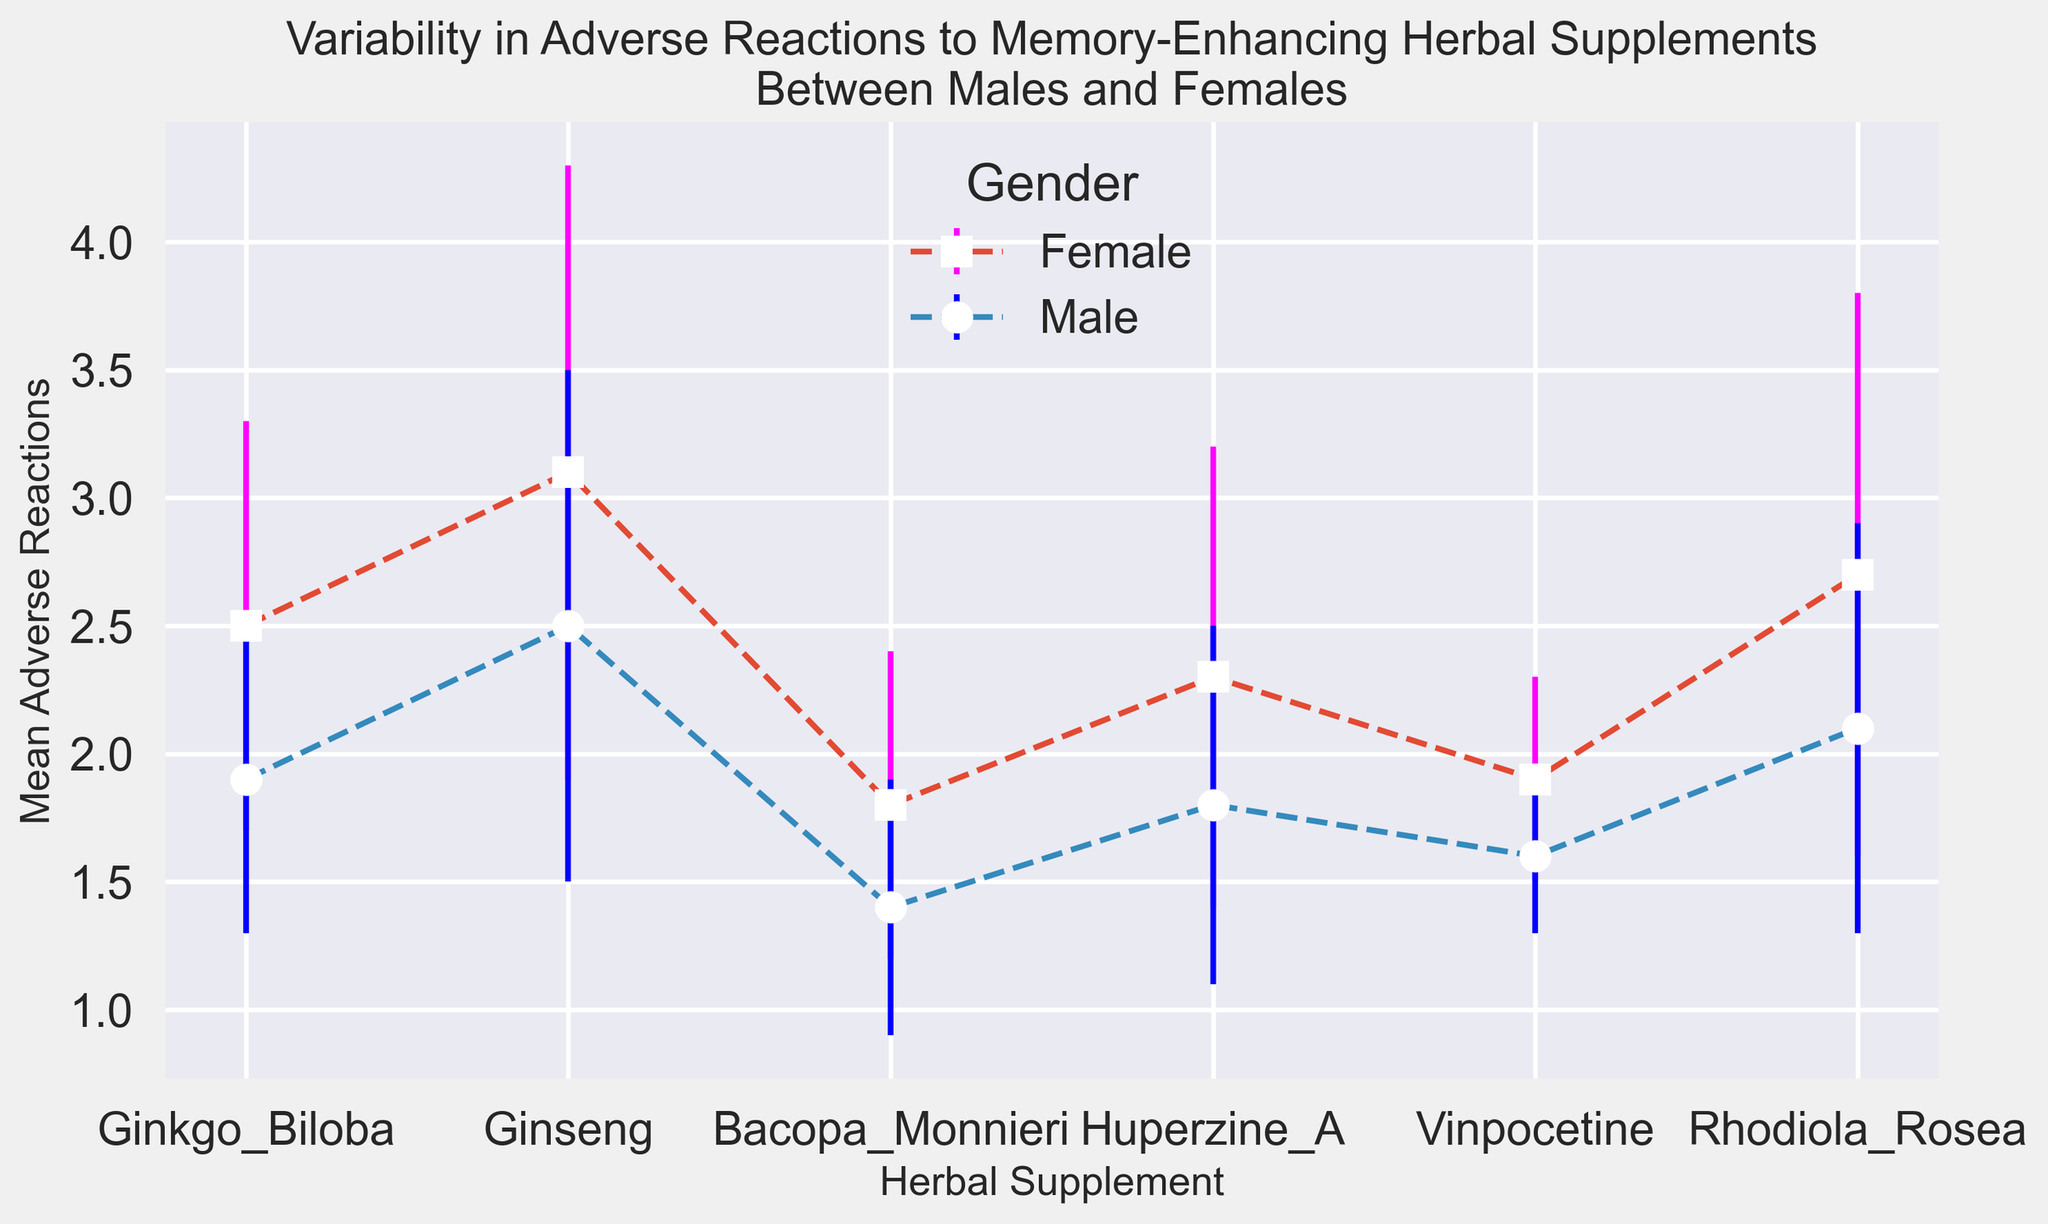What is the average mean adverse reaction for Ginkgo Biloba between males and females? To calculate the average mean adverse reaction for Ginkgo Biloba, add the mean values for males (1.9) and females (2.5), then divide by 2: (1.9 + 2.5) / 2 = 2.2
Answer: 2.2 Which herbal supplement shows the greatest difference in mean adverse reactions between males and females? Look at the difference in mean reactions for each supplement: Ginseng (3.1 - 2.5 = 0.6), Ginkgo Biloba (2.5 - 1.9 = 0.6), Bacopa Monnieri (1.8 - 1.4 = 0.4), Huperzine A (2.3 - 1.8 = 0.5), Vinpocetine (1.9 - 1.6 = 0.3), Rhodiola Rosea (2.7 - 2.1 = 0.6). The greatest difference is for Ginseng, Ginkgo Biloba, and Rhodiola Rosea with a difference of 0.6
Answer: Ginseng, Ginkgo Biloba, Rhodiola Rosea Between males and females, which gender had higher mean adverse reactions for Huperzine A? Compare the mean adverse reactions: males (1.8) and females (2.3). Females had higher mean adverse reactions
Answer: Females For males, which supplement has the lowest variability in adverse reactions? Look at the standard deviation of adverse reactions for males: Ginkgo Biloba (0.6), Ginseng (1.0), Bacopa Monnieri (0.5), Huperzine A (0.7), Vinpocetine (0.3), Rhodiola Rosea (0.8). Vinpocetine has the lowest standard deviation, indicating the lowest variability
Answer: Vinpocetine Which herbal supplement has the highest mean adverse reaction for females? Compare the mean adverse reactions for females: Ginkgo Biloba (2.5), Ginseng (3.1), Bacopa Monnieri (1.8), Huperzine A (2.3), Vinpocetine (1.9), Rhodiola Rosea (2.7). Ginseng has the highest mean adverse reaction at 3.1
Answer: Ginseng Which herbal supplement has the largest standard deviation in adverse reactions for females? Compare the standard deviations for females: Ginkgo Biloba (0.8), Ginseng (1.2), Bacopa Monnieri (0.6), Huperzine A (0.9), Vinpocetine (0.4), Rhodiola Rosea (1.1). Ginseng has the largest standard deviation at 1.2
Answer: Ginseng Is there any supplement for which males and females have the same standard deviation in adverse reactions? Compare the standard deviations for each supplement: Ginkgo Biloba (males: 0.6, females: 0.8), Ginseng (males: 1.0, females: 1.2), Bacopa Monnieri (males: 0.5, females: 0.6), Huperzine A (males: 0.7, females: 0.9), Vinpocetine (males: 0.3, females: 0.4), Rhodiola Rosea (males: 0.8, females: 1.1). No supplements have the same standard deviation in adverse reactions between genders
Answer: No What is the range of mean adverse reactions for males? To find the range, subtract the smallest mean adverse reaction value from the largest one for males: 2.5 (highest for Ginseng) - 1.4 (lowest for Bacopa Monnieri) = 1.1
Answer: 1.1 